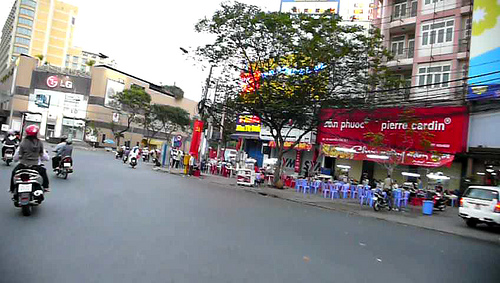How busy does this street appear to be? The street looks moderately busy, with multiple motorcycles and a few pedestrians visible, reflecting a bustling city environment. 